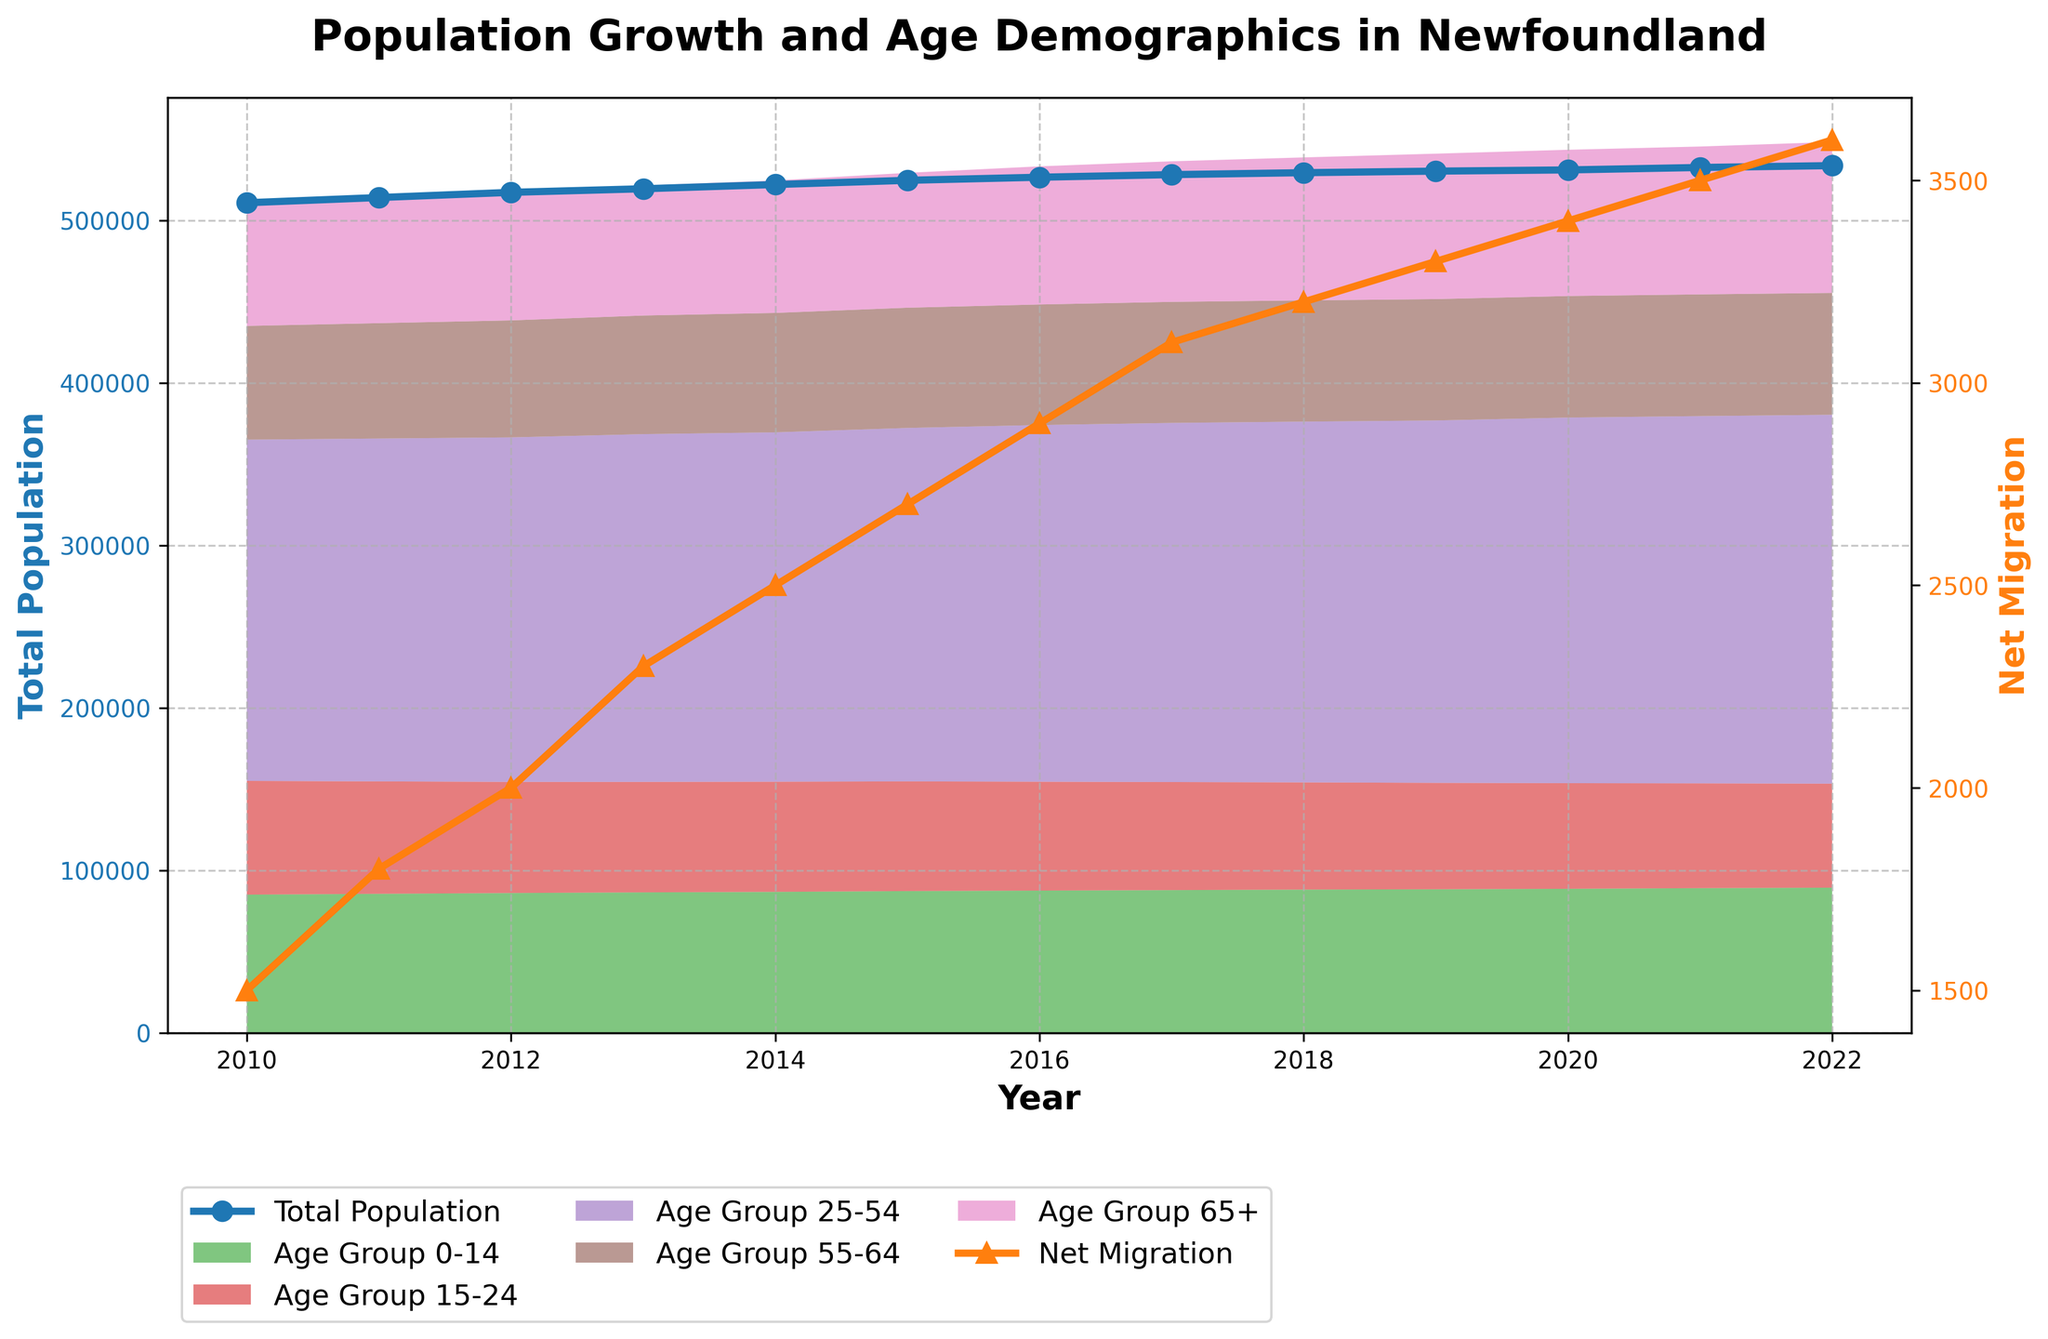How has the total population in Newfoundland changed from 2010 to 2022? The total population for each year is plotted as a line with markers. By following this line, we see the total population increases from 510,800 in 2010 to 533,650 in 2022.
Answer: Increased What is the trend of net migration between 2010 and 2022? The net migration line with triangles shows an upward trajectory from 1,500 in 2010 to 3,600 in 2022, indicating increasing net migration over this period.
Answer: Increasing Which age group shows the most significant increase in population from 2010 to 2022? By comparing the stacked area segments, the "Age Group 65+" shows the most significant increase, rising from 75,000 in 2010 to 92,900 in 2022.
Answer: Age Group 65+ Was net migration higher or lower in 2015 compared to 2012? The net migration line shows that in 2015 the value is 2,700, while in 2012 the value is 2,000. Therefore, net migration was higher in 2015.
Answer: Higher How does the population of the age group 25-54 in 2022 compare to that in 2010? The population of the age group 25-54 was 210,000 in 2010 and increased to 227,000 in 2022, indicating a growth over this period.
Answer: Increased What is the difference in the population of Age Group 0-14 between 2010 and 2022? The population in the Age Group 0-14 was 85,000 in 2010 and 89,300 in 2022. The difference is 89,300 - 85,000 = 4,300.
Answer: 4,300 Which year shows the highest net migration? By observing the Net Migration line, 2022 shows the highest net migration value of 3,600.
Answer: 2022 What is the overall trend in the population of the age group 15-24 from 2010 to 2022? The Age Group 15-24 shows a declining trend, starting at 70,000 in 2010 and dropping to 64,000 in 2022.
Answer: Decreasing How does the total population correlate with net migration over the years? Both the total population and net migration trend lines show an upward trajectory, indicating a positive correlation between them.
Answer: Positive correlation What are the key differences in population dynamics between Age Group 0-14 and Age Group 65+ over the given period? The Age Group 0-14 shows a smaller relative increase from 85,000 in 2010 to 89,300 in 2022, whereas Age Group 65+ shows a substantial increase from 75,000 to 92,900 in the same period.
Answer: Age Group 0-14: smaller increase, Age Group 65+: substantial increase 